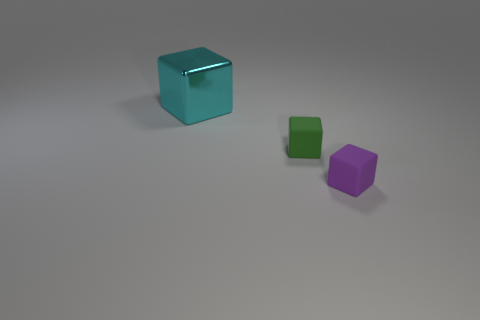There is another metallic thing that is the same shape as the green object; what is its color?
Ensure brevity in your answer.  Cyan. What material is the object behind the small green object?
Your answer should be compact. Metal. The big metal cube is what color?
Keep it short and to the point. Cyan. Do the matte cube in front of the green matte block and the green block have the same size?
Your response must be concise. Yes. What is the material of the thing that is behind the matte thing that is on the left side of the small cube that is on the right side of the green rubber block?
Offer a terse response. Metal. What material is the object that is to the left of the matte object that is to the left of the purple object?
Offer a very short reply. Metal. There is another block that is the same size as the purple rubber cube; what color is it?
Give a very brief answer. Green. Is the shape of the green matte thing the same as the object that is in front of the green matte cube?
Provide a short and direct response. Yes. How many tiny matte objects are behind the tiny object that is to the left of the matte thing that is on the right side of the tiny green rubber object?
Provide a short and direct response. 0. What is the size of the thing that is to the right of the tiny block that is behind the tiny purple block?
Keep it short and to the point. Small. 